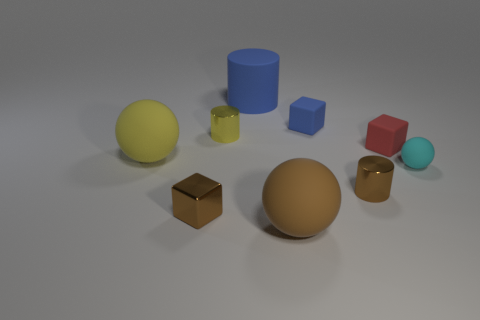Does the large sphere behind the small matte ball have the same color as the rubber cylinder?
Your answer should be compact. No. The blue rubber object that is the same shape as the red object is what size?
Your response must be concise. Small. The cylinder that is right of the big ball in front of the cyan sphere right of the yellow shiny cylinder is what color?
Ensure brevity in your answer.  Brown. Are the blue block and the cyan sphere made of the same material?
Provide a succinct answer. Yes. There is a rubber cube on the right side of the small cylinder that is to the right of the big cylinder; is there a tiny brown metallic block on the right side of it?
Keep it short and to the point. No. Is the color of the small rubber ball the same as the tiny shiny cube?
Provide a succinct answer. No. Are there fewer big yellow rubber cubes than tiny brown blocks?
Give a very brief answer. Yes. Is the material of the cube that is in front of the red rubber thing the same as the sphere that is in front of the cyan matte ball?
Your answer should be very brief. No. Are there fewer tiny objects behind the cyan ball than tiny matte things?
Your answer should be compact. No. How many cylinders are left of the ball that is to the left of the large blue thing?
Your answer should be compact. 0. 